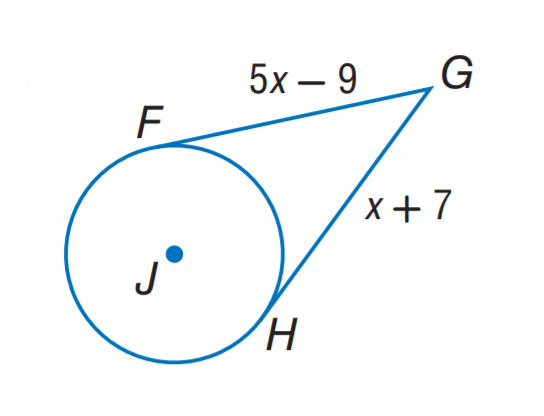Question: The segment is tangent to the circle. Find x.
Choices:
A. 4
B. 5
C. 7
D. 9
Answer with the letter. Answer: A 